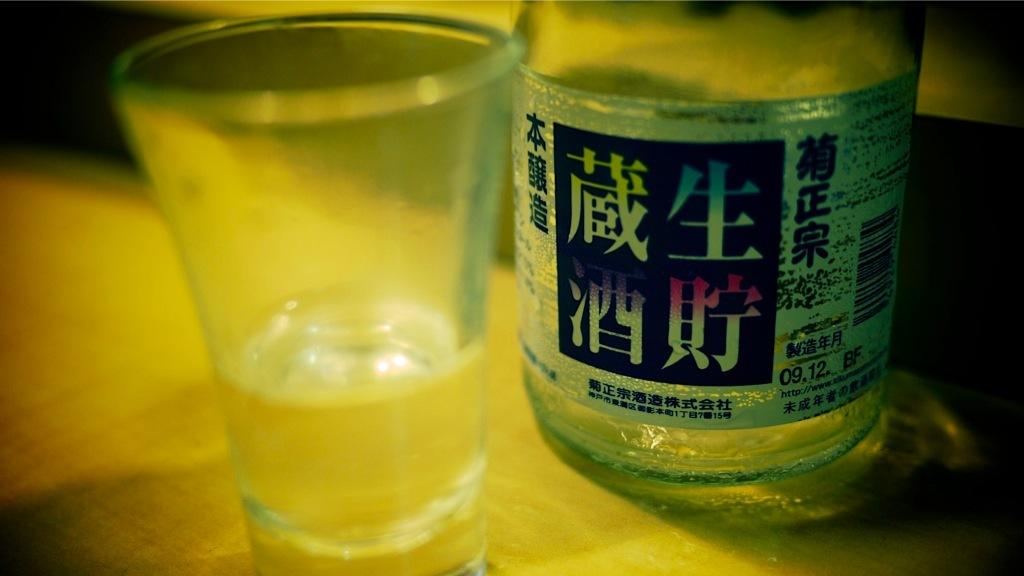<image>
Relay a brief, clear account of the picture shown. A drinking glass next to a bottle written in kanji characters, with the date 09.12 